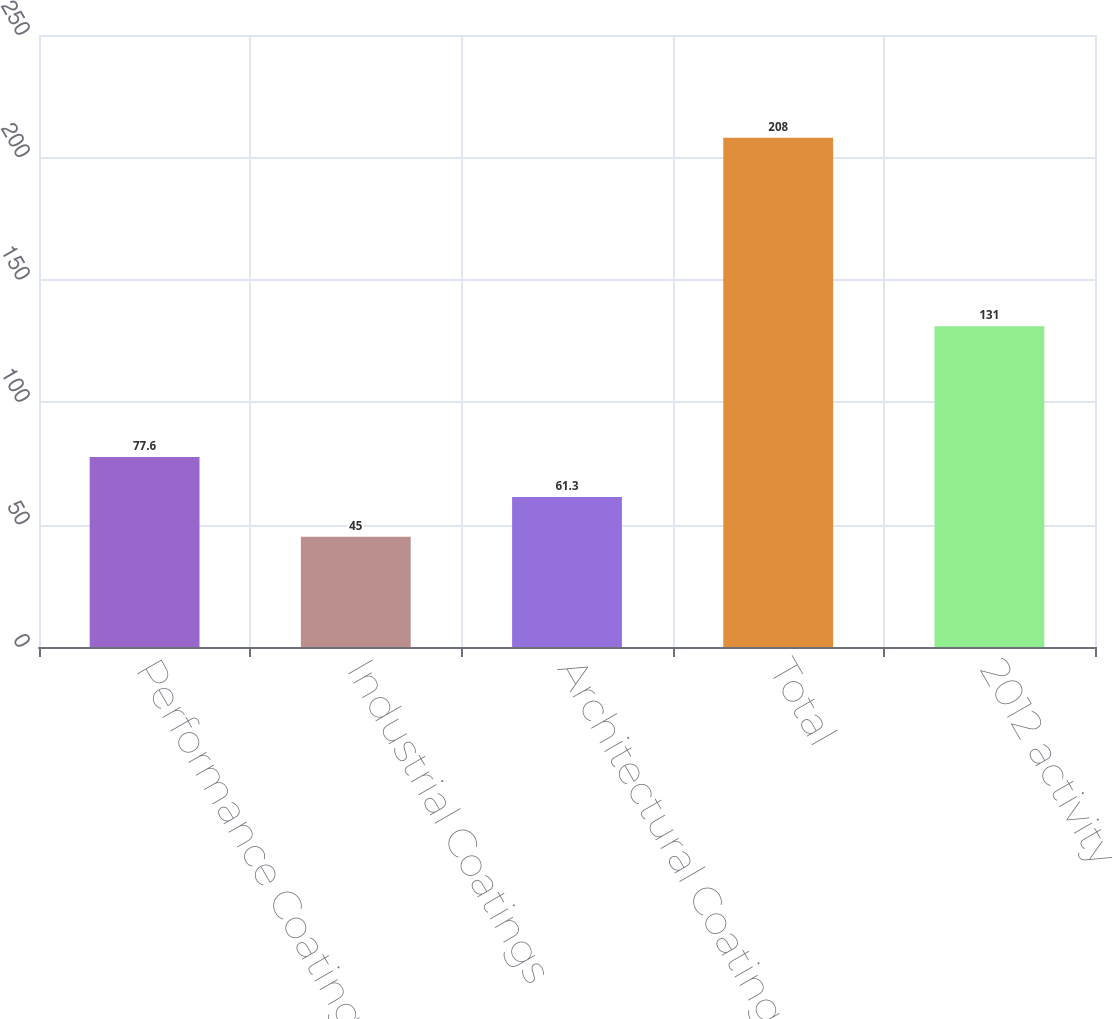Convert chart. <chart><loc_0><loc_0><loc_500><loc_500><bar_chart><fcel>Performance Coatings<fcel>Industrial Coatings<fcel>Architectural Coatings - EMEA<fcel>Total<fcel>2012 activity<nl><fcel>77.6<fcel>45<fcel>61.3<fcel>208<fcel>131<nl></chart> 